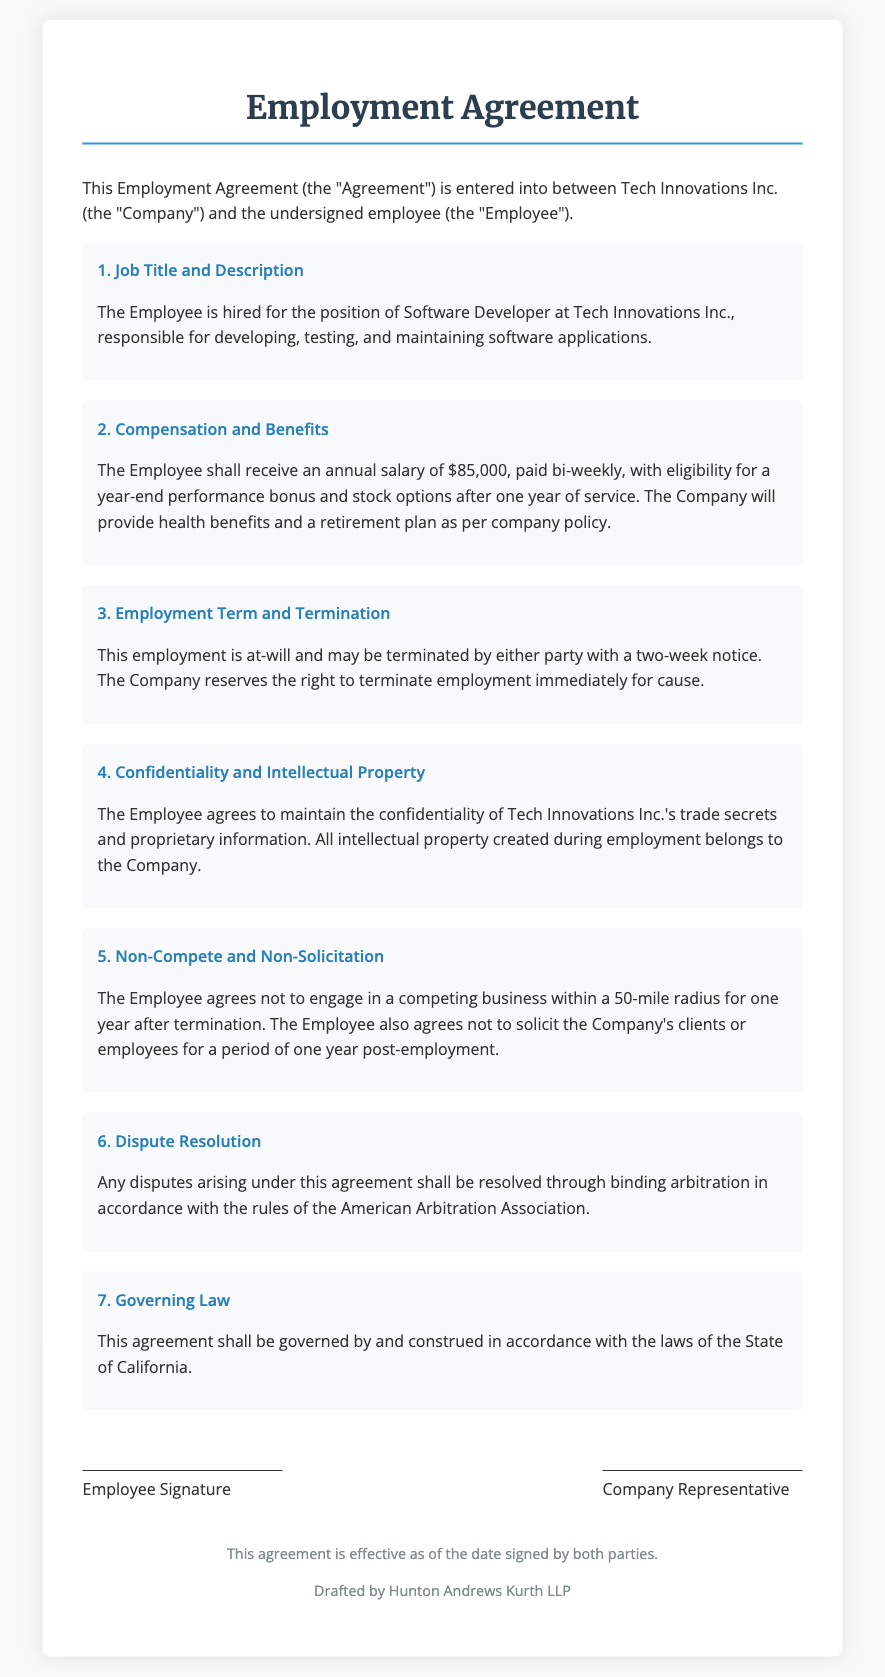What is the job title of the Employee? The job title of the Employee is mentioned in the section on Job Title and Description.
Answer: Software Developer What is the annual salary stated in the agreement? The annual salary is specified in the Compensation and Benefits section.
Answer: $85,000 What is the notice period for termination of employment? The notice period for termination is described in the Employment Term and Termination section.
Answer: Two weeks What are the health benefits provided by the Company? The health benefits are mentioned in the Compensation and Benefits section.
Answer: Health benefits What is the duration of the non-compete agreement? The non-compete agreement duration is outlined in the Non-Compete and Non-Solicitation section.
Answer: One year What type of dispute resolution is included in this agreement? The dispute resolution method is described in the Dispute Resolution section.
Answer: Binding arbitration Which state's laws govern this agreement? The governing law is specified in the Governing Law section.
Answer: California What type of information is the Employee required to keep confidential? The type of information is stated in the Confidentiality and Intellectual Property section.
Answer: Trade secrets What is the duration for which the Employee cannot solicit clients post-employment? The duration for non-solicitation is specified in the Non-Compete and Non-Solicitation section.
Answer: One year 